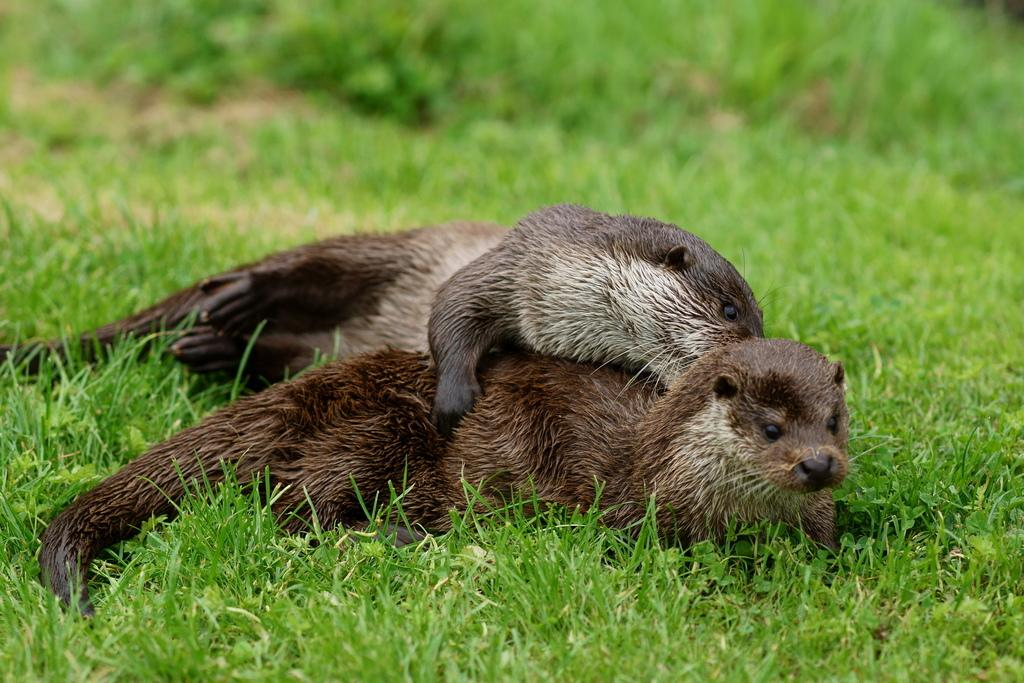What is the number of animals present in the image? There are two animals in the image. What is the animals' position in the image? The animals are lying on the grass. How are the animals positioned in relation to each other? The animals are lying next to each other. What type of seed is being used by the maid in the image? There is no maid or seed present in the image. 